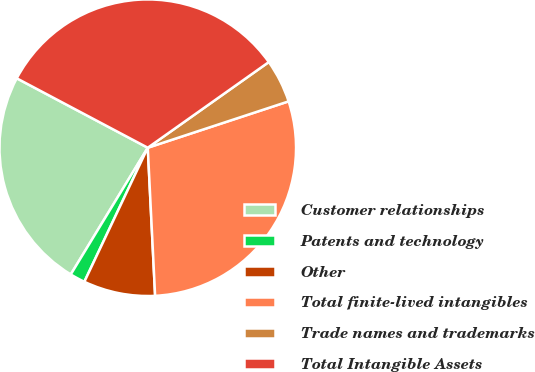<chart> <loc_0><loc_0><loc_500><loc_500><pie_chart><fcel>Customer relationships<fcel>Patents and technology<fcel>Other<fcel>Total finite-lived intangibles<fcel>Trade names and trademarks<fcel>Total Intangible Assets<nl><fcel>24.06%<fcel>1.66%<fcel>7.82%<fcel>29.27%<fcel>4.74%<fcel>32.44%<nl></chart> 